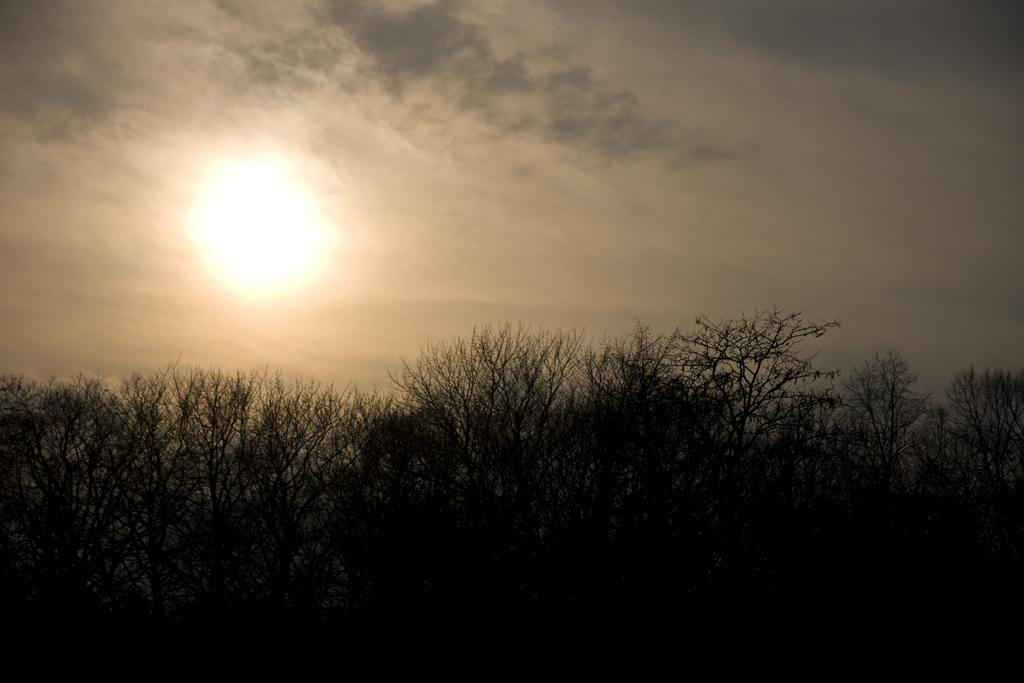Where was the image taken? The image was taken outdoors. What can be seen at the bottom of the image? There are trees and plants at the bottom of the image. What is visible at the top of the image? There is a sky visible at the top of the image. What can be observed in the sky? Clouds and the sun are present in the sky. Are the sisters in the image discussing their agreement about the toad? There are no sisters or toads present in the image, so it is not possible to answer that question. 